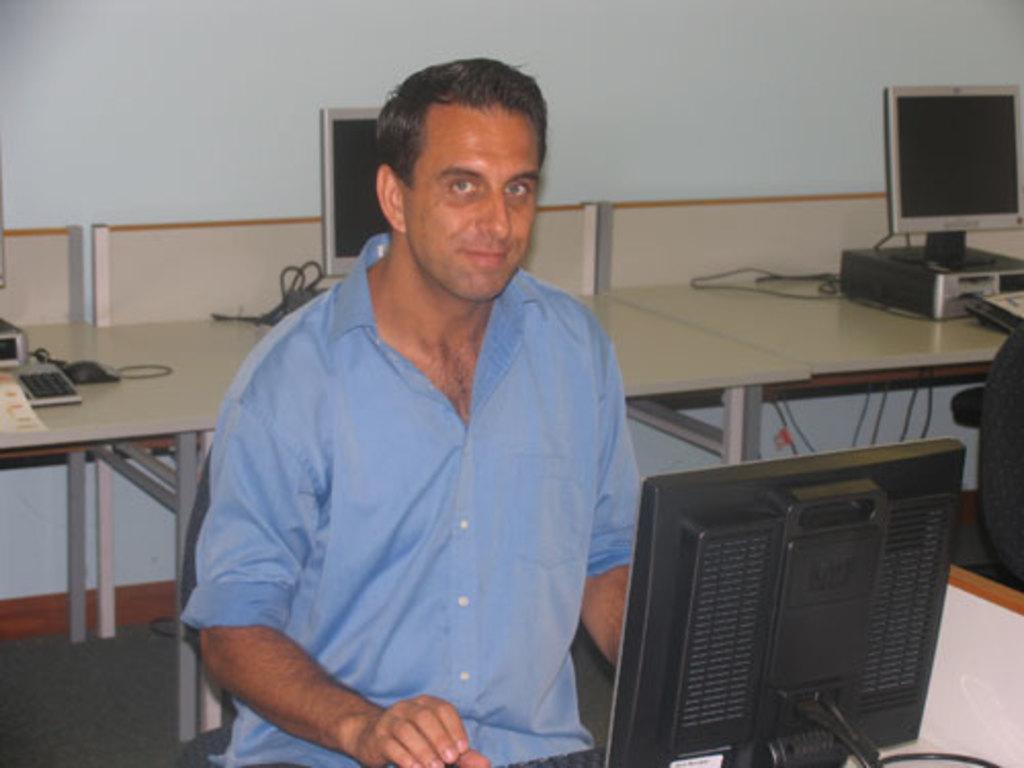Describe this image in one or two sentences. In this picture there is a man who is wearing blue shirt. He is sitting on the chair. He is working on the computer. in the back we can see computer screen, CPU, cables, keyboards, mouse, mat and paper on the table. 